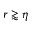<formula> <loc_0><loc_0><loc_500><loc_500>r \gtrapprox \eta</formula> 